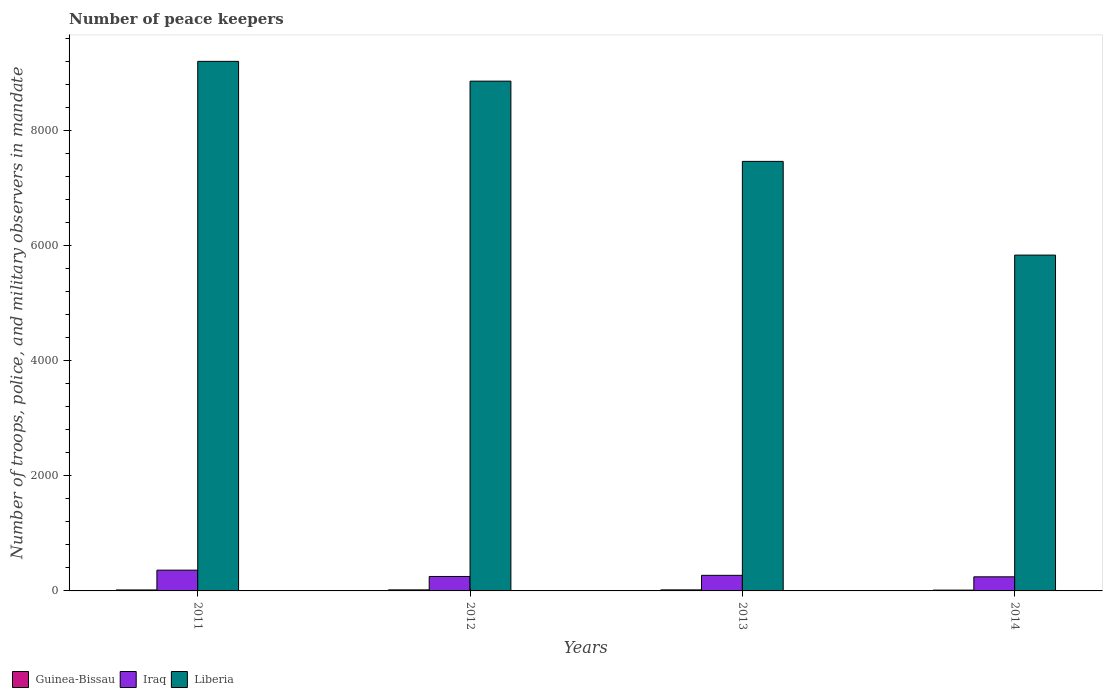How many different coloured bars are there?
Offer a terse response. 3. How many groups of bars are there?
Offer a terse response. 4. Are the number of bars per tick equal to the number of legend labels?
Provide a short and direct response. Yes. Are the number of bars on each tick of the X-axis equal?
Make the answer very short. Yes. How many bars are there on the 1st tick from the right?
Your response must be concise. 3. What is the number of peace keepers in in Liberia in 2013?
Make the answer very short. 7467. Across all years, what is the minimum number of peace keepers in in Iraq?
Your answer should be very brief. 245. What is the difference between the number of peace keepers in in Liberia in 2012 and that in 2013?
Keep it short and to the point. 1395. What is the difference between the number of peace keepers in in Iraq in 2014 and the number of peace keepers in in Liberia in 2013?
Ensure brevity in your answer.  -7222. What is the average number of peace keepers in in Guinea-Bissau per year?
Provide a succinct answer. 16.75. In the year 2011, what is the difference between the number of peace keepers in in Liberia and number of peace keepers in in Iraq?
Offer a very short reply. 8845. In how many years, is the number of peace keepers in in Iraq greater than 5200?
Make the answer very short. 0. What is the ratio of the number of peace keepers in in Guinea-Bissau in 2012 to that in 2014?
Provide a succinct answer. 1.29. Is the difference between the number of peace keepers in in Liberia in 2012 and 2013 greater than the difference between the number of peace keepers in in Iraq in 2012 and 2013?
Give a very brief answer. Yes. What is the difference between the highest and the second highest number of peace keepers in in Liberia?
Give a very brief answer. 344. What is the difference between the highest and the lowest number of peace keepers in in Liberia?
Offer a terse response. 3368. What does the 1st bar from the left in 2012 represents?
Your answer should be very brief. Guinea-Bissau. What does the 3rd bar from the right in 2014 represents?
Provide a succinct answer. Guinea-Bissau. Is it the case that in every year, the sum of the number of peace keepers in in Guinea-Bissau and number of peace keepers in in Liberia is greater than the number of peace keepers in in Iraq?
Your answer should be very brief. Yes. How many years are there in the graph?
Keep it short and to the point. 4. Does the graph contain any zero values?
Provide a succinct answer. No. Where does the legend appear in the graph?
Provide a short and direct response. Bottom left. How are the legend labels stacked?
Make the answer very short. Horizontal. What is the title of the graph?
Provide a succinct answer. Number of peace keepers. What is the label or title of the X-axis?
Provide a succinct answer. Years. What is the label or title of the Y-axis?
Your response must be concise. Number of troops, police, and military observers in mandate. What is the Number of troops, police, and military observers in mandate in Guinea-Bissau in 2011?
Offer a terse response. 17. What is the Number of troops, police, and military observers in mandate in Iraq in 2011?
Give a very brief answer. 361. What is the Number of troops, police, and military observers in mandate of Liberia in 2011?
Your answer should be very brief. 9206. What is the Number of troops, police, and military observers in mandate of Iraq in 2012?
Offer a very short reply. 251. What is the Number of troops, police, and military observers in mandate of Liberia in 2012?
Offer a very short reply. 8862. What is the Number of troops, police, and military observers in mandate of Iraq in 2013?
Offer a terse response. 271. What is the Number of troops, police, and military observers in mandate in Liberia in 2013?
Provide a succinct answer. 7467. What is the Number of troops, police, and military observers in mandate of Guinea-Bissau in 2014?
Your answer should be very brief. 14. What is the Number of troops, police, and military observers in mandate of Iraq in 2014?
Your response must be concise. 245. What is the Number of troops, police, and military observers in mandate of Liberia in 2014?
Make the answer very short. 5838. Across all years, what is the maximum Number of troops, police, and military observers in mandate in Guinea-Bissau?
Provide a succinct answer. 18. Across all years, what is the maximum Number of troops, police, and military observers in mandate in Iraq?
Your response must be concise. 361. Across all years, what is the maximum Number of troops, police, and military observers in mandate of Liberia?
Your answer should be compact. 9206. Across all years, what is the minimum Number of troops, police, and military observers in mandate of Iraq?
Your answer should be compact. 245. Across all years, what is the minimum Number of troops, police, and military observers in mandate of Liberia?
Offer a terse response. 5838. What is the total Number of troops, police, and military observers in mandate of Guinea-Bissau in the graph?
Ensure brevity in your answer.  67. What is the total Number of troops, police, and military observers in mandate in Iraq in the graph?
Your answer should be compact. 1128. What is the total Number of troops, police, and military observers in mandate of Liberia in the graph?
Keep it short and to the point. 3.14e+04. What is the difference between the Number of troops, police, and military observers in mandate of Iraq in 2011 and that in 2012?
Keep it short and to the point. 110. What is the difference between the Number of troops, police, and military observers in mandate in Liberia in 2011 and that in 2012?
Keep it short and to the point. 344. What is the difference between the Number of troops, police, and military observers in mandate in Iraq in 2011 and that in 2013?
Make the answer very short. 90. What is the difference between the Number of troops, police, and military observers in mandate of Liberia in 2011 and that in 2013?
Make the answer very short. 1739. What is the difference between the Number of troops, police, and military observers in mandate in Guinea-Bissau in 2011 and that in 2014?
Ensure brevity in your answer.  3. What is the difference between the Number of troops, police, and military observers in mandate of Iraq in 2011 and that in 2014?
Your answer should be very brief. 116. What is the difference between the Number of troops, police, and military observers in mandate of Liberia in 2011 and that in 2014?
Offer a very short reply. 3368. What is the difference between the Number of troops, police, and military observers in mandate of Iraq in 2012 and that in 2013?
Provide a succinct answer. -20. What is the difference between the Number of troops, police, and military observers in mandate of Liberia in 2012 and that in 2013?
Your response must be concise. 1395. What is the difference between the Number of troops, police, and military observers in mandate of Liberia in 2012 and that in 2014?
Offer a very short reply. 3024. What is the difference between the Number of troops, police, and military observers in mandate of Guinea-Bissau in 2013 and that in 2014?
Your answer should be very brief. 4. What is the difference between the Number of troops, police, and military observers in mandate of Liberia in 2013 and that in 2014?
Offer a very short reply. 1629. What is the difference between the Number of troops, police, and military observers in mandate of Guinea-Bissau in 2011 and the Number of troops, police, and military observers in mandate of Iraq in 2012?
Make the answer very short. -234. What is the difference between the Number of troops, police, and military observers in mandate in Guinea-Bissau in 2011 and the Number of troops, police, and military observers in mandate in Liberia in 2012?
Your answer should be compact. -8845. What is the difference between the Number of troops, police, and military observers in mandate of Iraq in 2011 and the Number of troops, police, and military observers in mandate of Liberia in 2012?
Your response must be concise. -8501. What is the difference between the Number of troops, police, and military observers in mandate in Guinea-Bissau in 2011 and the Number of troops, police, and military observers in mandate in Iraq in 2013?
Make the answer very short. -254. What is the difference between the Number of troops, police, and military observers in mandate of Guinea-Bissau in 2011 and the Number of troops, police, and military observers in mandate of Liberia in 2013?
Give a very brief answer. -7450. What is the difference between the Number of troops, police, and military observers in mandate of Iraq in 2011 and the Number of troops, police, and military observers in mandate of Liberia in 2013?
Your response must be concise. -7106. What is the difference between the Number of troops, police, and military observers in mandate in Guinea-Bissau in 2011 and the Number of troops, police, and military observers in mandate in Iraq in 2014?
Offer a very short reply. -228. What is the difference between the Number of troops, police, and military observers in mandate of Guinea-Bissau in 2011 and the Number of troops, police, and military observers in mandate of Liberia in 2014?
Provide a short and direct response. -5821. What is the difference between the Number of troops, police, and military observers in mandate of Iraq in 2011 and the Number of troops, police, and military observers in mandate of Liberia in 2014?
Your answer should be compact. -5477. What is the difference between the Number of troops, police, and military observers in mandate of Guinea-Bissau in 2012 and the Number of troops, police, and military observers in mandate of Iraq in 2013?
Ensure brevity in your answer.  -253. What is the difference between the Number of troops, police, and military observers in mandate of Guinea-Bissau in 2012 and the Number of troops, police, and military observers in mandate of Liberia in 2013?
Your answer should be very brief. -7449. What is the difference between the Number of troops, police, and military observers in mandate of Iraq in 2012 and the Number of troops, police, and military observers in mandate of Liberia in 2013?
Offer a very short reply. -7216. What is the difference between the Number of troops, police, and military observers in mandate of Guinea-Bissau in 2012 and the Number of troops, police, and military observers in mandate of Iraq in 2014?
Provide a short and direct response. -227. What is the difference between the Number of troops, police, and military observers in mandate in Guinea-Bissau in 2012 and the Number of troops, police, and military observers in mandate in Liberia in 2014?
Your answer should be compact. -5820. What is the difference between the Number of troops, police, and military observers in mandate of Iraq in 2012 and the Number of troops, police, and military observers in mandate of Liberia in 2014?
Make the answer very short. -5587. What is the difference between the Number of troops, police, and military observers in mandate of Guinea-Bissau in 2013 and the Number of troops, police, and military observers in mandate of Iraq in 2014?
Ensure brevity in your answer.  -227. What is the difference between the Number of troops, police, and military observers in mandate of Guinea-Bissau in 2013 and the Number of troops, police, and military observers in mandate of Liberia in 2014?
Offer a terse response. -5820. What is the difference between the Number of troops, police, and military observers in mandate in Iraq in 2013 and the Number of troops, police, and military observers in mandate in Liberia in 2014?
Your answer should be compact. -5567. What is the average Number of troops, police, and military observers in mandate of Guinea-Bissau per year?
Your answer should be compact. 16.75. What is the average Number of troops, police, and military observers in mandate of Iraq per year?
Offer a very short reply. 282. What is the average Number of troops, police, and military observers in mandate of Liberia per year?
Provide a short and direct response. 7843.25. In the year 2011, what is the difference between the Number of troops, police, and military observers in mandate in Guinea-Bissau and Number of troops, police, and military observers in mandate in Iraq?
Give a very brief answer. -344. In the year 2011, what is the difference between the Number of troops, police, and military observers in mandate of Guinea-Bissau and Number of troops, police, and military observers in mandate of Liberia?
Make the answer very short. -9189. In the year 2011, what is the difference between the Number of troops, police, and military observers in mandate in Iraq and Number of troops, police, and military observers in mandate in Liberia?
Provide a short and direct response. -8845. In the year 2012, what is the difference between the Number of troops, police, and military observers in mandate in Guinea-Bissau and Number of troops, police, and military observers in mandate in Iraq?
Provide a succinct answer. -233. In the year 2012, what is the difference between the Number of troops, police, and military observers in mandate in Guinea-Bissau and Number of troops, police, and military observers in mandate in Liberia?
Keep it short and to the point. -8844. In the year 2012, what is the difference between the Number of troops, police, and military observers in mandate of Iraq and Number of troops, police, and military observers in mandate of Liberia?
Provide a succinct answer. -8611. In the year 2013, what is the difference between the Number of troops, police, and military observers in mandate in Guinea-Bissau and Number of troops, police, and military observers in mandate in Iraq?
Your answer should be very brief. -253. In the year 2013, what is the difference between the Number of troops, police, and military observers in mandate in Guinea-Bissau and Number of troops, police, and military observers in mandate in Liberia?
Give a very brief answer. -7449. In the year 2013, what is the difference between the Number of troops, police, and military observers in mandate of Iraq and Number of troops, police, and military observers in mandate of Liberia?
Offer a terse response. -7196. In the year 2014, what is the difference between the Number of troops, police, and military observers in mandate in Guinea-Bissau and Number of troops, police, and military observers in mandate in Iraq?
Provide a succinct answer. -231. In the year 2014, what is the difference between the Number of troops, police, and military observers in mandate of Guinea-Bissau and Number of troops, police, and military observers in mandate of Liberia?
Your answer should be very brief. -5824. In the year 2014, what is the difference between the Number of troops, police, and military observers in mandate of Iraq and Number of troops, police, and military observers in mandate of Liberia?
Offer a very short reply. -5593. What is the ratio of the Number of troops, police, and military observers in mandate of Guinea-Bissau in 2011 to that in 2012?
Make the answer very short. 0.94. What is the ratio of the Number of troops, police, and military observers in mandate in Iraq in 2011 to that in 2012?
Keep it short and to the point. 1.44. What is the ratio of the Number of troops, police, and military observers in mandate of Liberia in 2011 to that in 2012?
Provide a succinct answer. 1.04. What is the ratio of the Number of troops, police, and military observers in mandate of Guinea-Bissau in 2011 to that in 2013?
Make the answer very short. 0.94. What is the ratio of the Number of troops, police, and military observers in mandate in Iraq in 2011 to that in 2013?
Provide a succinct answer. 1.33. What is the ratio of the Number of troops, police, and military observers in mandate of Liberia in 2011 to that in 2013?
Make the answer very short. 1.23. What is the ratio of the Number of troops, police, and military observers in mandate in Guinea-Bissau in 2011 to that in 2014?
Your answer should be compact. 1.21. What is the ratio of the Number of troops, police, and military observers in mandate in Iraq in 2011 to that in 2014?
Provide a short and direct response. 1.47. What is the ratio of the Number of troops, police, and military observers in mandate of Liberia in 2011 to that in 2014?
Offer a very short reply. 1.58. What is the ratio of the Number of troops, police, and military observers in mandate of Iraq in 2012 to that in 2013?
Offer a terse response. 0.93. What is the ratio of the Number of troops, police, and military observers in mandate of Liberia in 2012 to that in 2013?
Keep it short and to the point. 1.19. What is the ratio of the Number of troops, police, and military observers in mandate of Guinea-Bissau in 2012 to that in 2014?
Offer a terse response. 1.29. What is the ratio of the Number of troops, police, and military observers in mandate in Iraq in 2012 to that in 2014?
Offer a very short reply. 1.02. What is the ratio of the Number of troops, police, and military observers in mandate in Liberia in 2012 to that in 2014?
Keep it short and to the point. 1.52. What is the ratio of the Number of troops, police, and military observers in mandate in Guinea-Bissau in 2013 to that in 2014?
Your response must be concise. 1.29. What is the ratio of the Number of troops, police, and military observers in mandate of Iraq in 2013 to that in 2014?
Give a very brief answer. 1.11. What is the ratio of the Number of troops, police, and military observers in mandate in Liberia in 2013 to that in 2014?
Offer a terse response. 1.28. What is the difference between the highest and the second highest Number of troops, police, and military observers in mandate in Guinea-Bissau?
Provide a succinct answer. 0. What is the difference between the highest and the second highest Number of troops, police, and military observers in mandate in Liberia?
Provide a succinct answer. 344. What is the difference between the highest and the lowest Number of troops, police, and military observers in mandate of Guinea-Bissau?
Offer a terse response. 4. What is the difference between the highest and the lowest Number of troops, police, and military observers in mandate in Iraq?
Offer a terse response. 116. What is the difference between the highest and the lowest Number of troops, police, and military observers in mandate of Liberia?
Provide a short and direct response. 3368. 